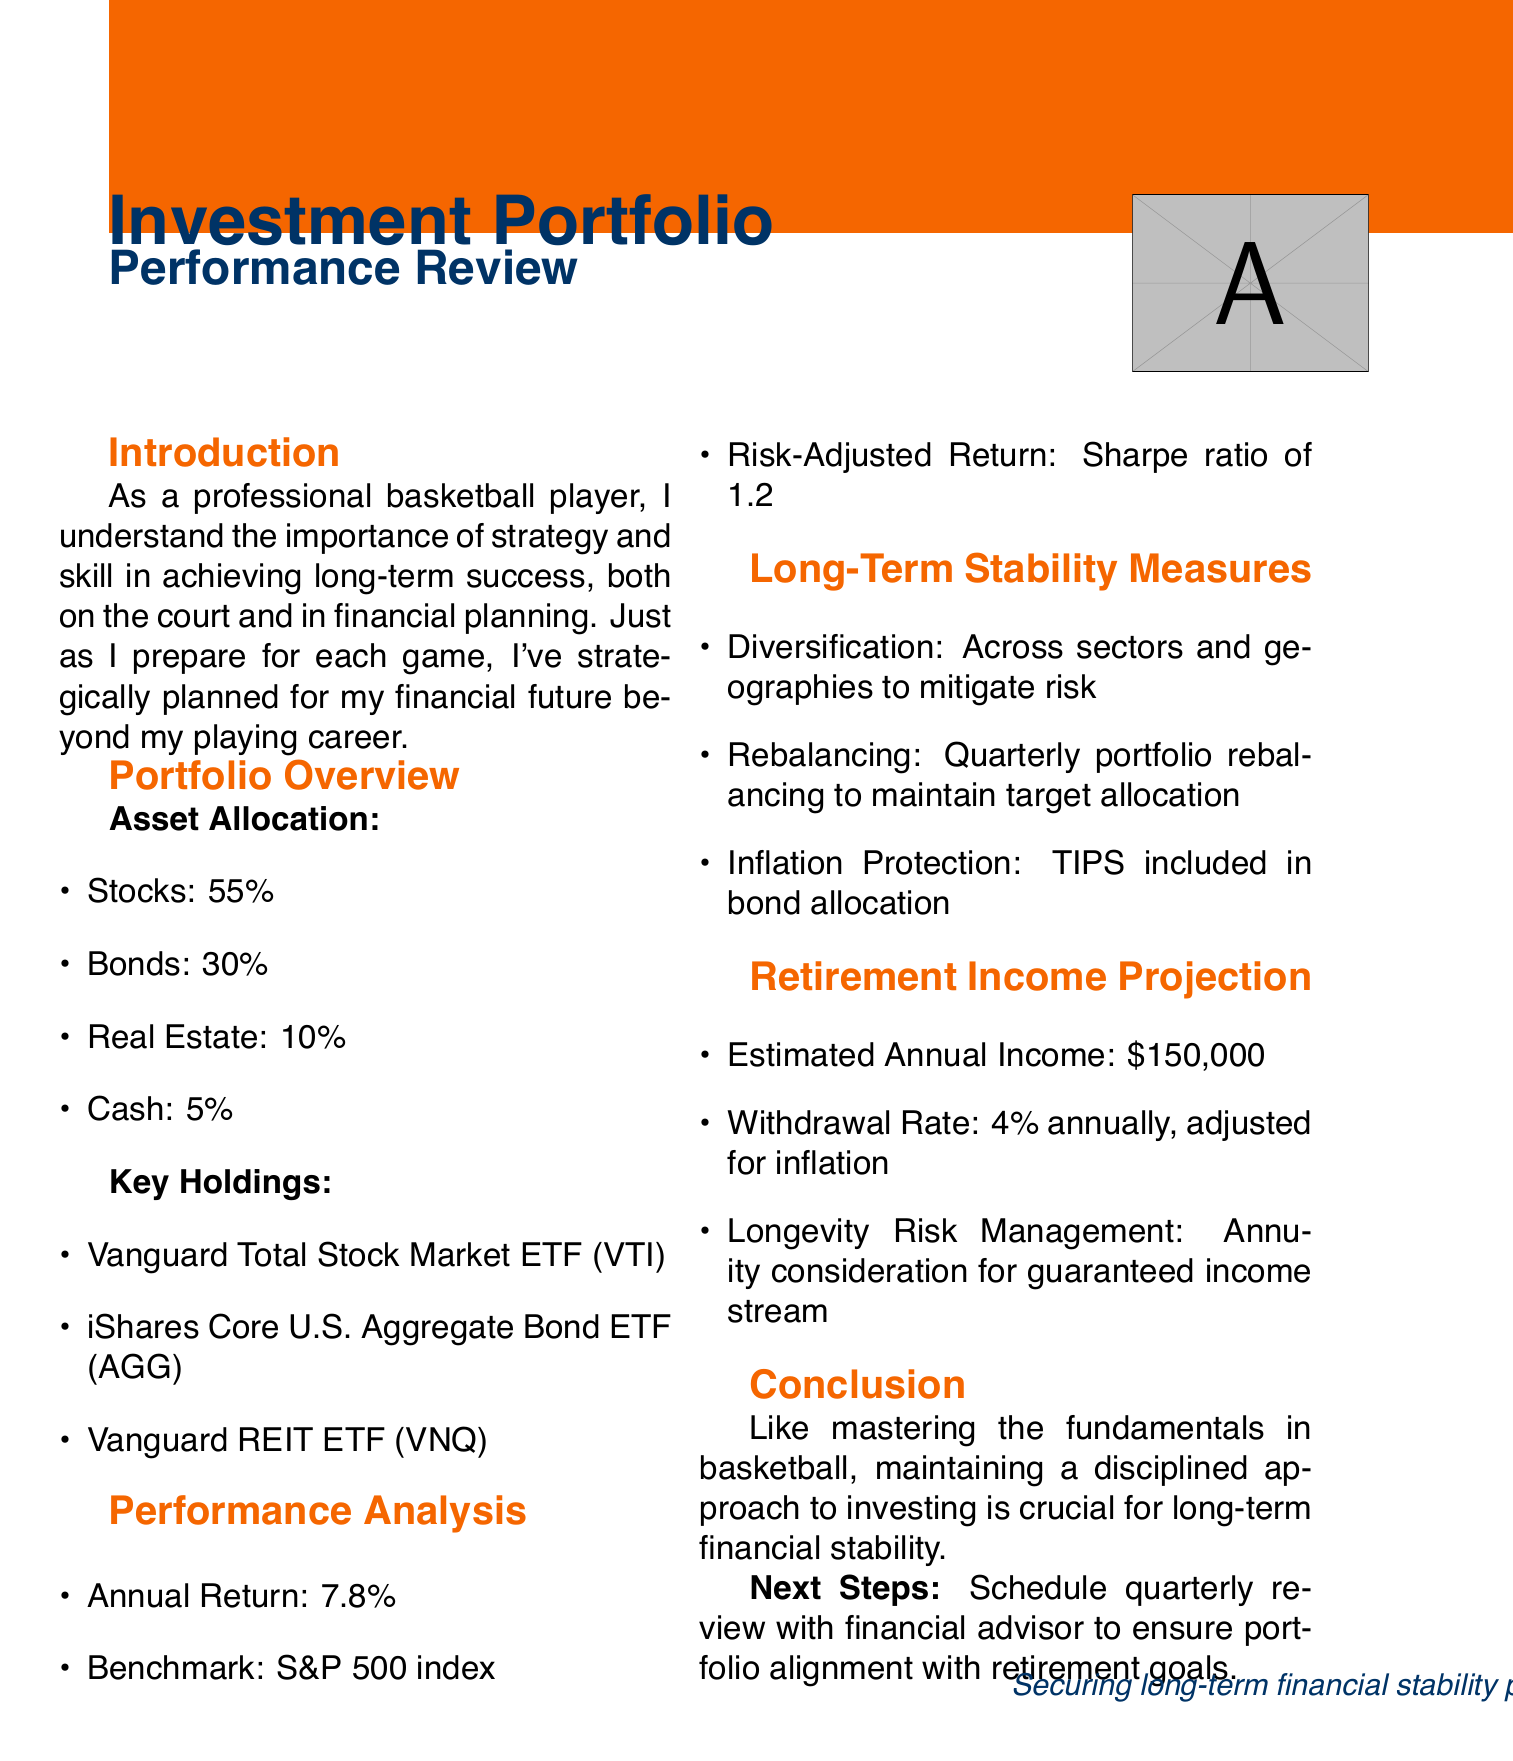What is the title of the document? The title is clearly stated at the beginning of the document.
Answer: Investment Portfolio Performance Review: Securing Long-Term Financial Stability Post-Retirement What percentage of the portfolio is allocated to stocks? The portfolio overview section lists the asset allocation, indicating the percentage for each asset class.
Answer: 55 What is the annual return of the portfolio? This information is provided in the performance analysis section, specifically stating the annual return figure.
Answer: 7.8 What is the Sharpe ratio of the portfolio? The risk-adjusted return is mentioned in the performance analysis section, specifically stating the Sharpe ratio.
Answer: 1.2 What is the estimated annual income post-retirement? The retirement income projection section provides this financial figure as part of the analysis.
Answer: $150,000 Which ETF is included in the key holdings? Several key holdings are listed, and one specific ETF must be identified from that list.
Answer: Vanguard Total Stock Market ETF (VTI) How often is the portfolio rebalanced? The long-term stability measures provide details about portfolio management, including the frequency of rebalancing.
Answer: Quarterly What is the withdrawal rate mentioned in the document? The retirement income projection clearly outlines the withdrawal rate for sustainable income during retirement.
Answer: 4% annually What is the key takeaway from the conclusion? The conclusion section emphasizes a critical principle of investing as compared to mastering a skill in sports.
Answer: Maintaining a disciplined approach to investing is crucial for long-term financial stability 